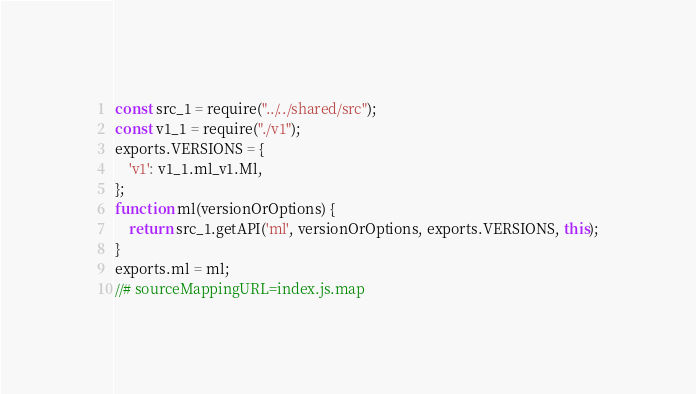<code> <loc_0><loc_0><loc_500><loc_500><_JavaScript_>const src_1 = require("../../shared/src");
const v1_1 = require("./v1");
exports.VERSIONS = {
    'v1': v1_1.ml_v1.Ml,
};
function ml(versionOrOptions) {
    return src_1.getAPI('ml', versionOrOptions, exports.VERSIONS, this);
}
exports.ml = ml;
//# sourceMappingURL=index.js.map</code> 